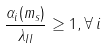Convert formula to latex. <formula><loc_0><loc_0><loc_500><loc_500>\frac { \alpha _ { i } ( m _ { s } ) } { \lambda _ { I I } } \geq 1 , \forall \, i</formula> 